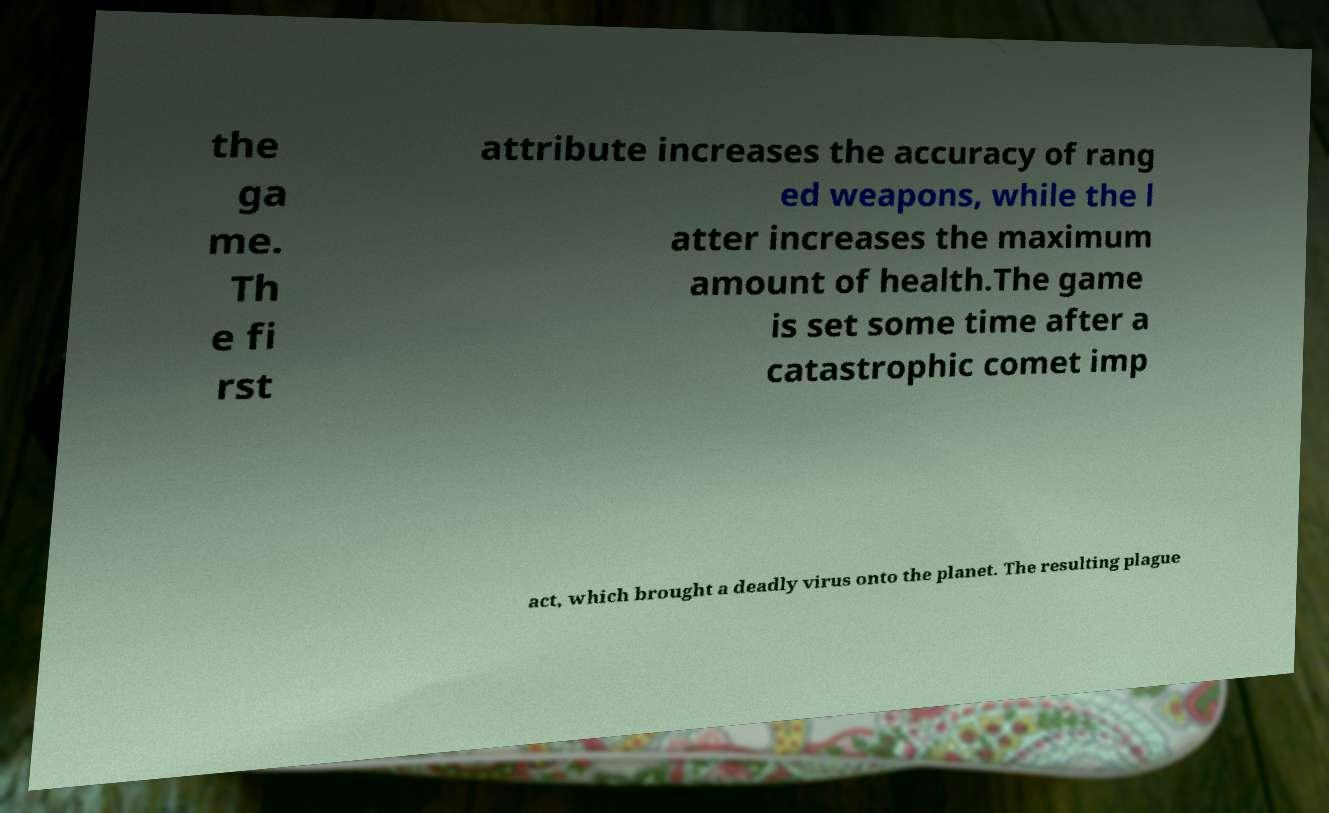Could you extract and type out the text from this image? the ga me. Th e fi rst attribute increases the accuracy of rang ed weapons, while the l atter increases the maximum amount of health.The game is set some time after a catastrophic comet imp act, which brought a deadly virus onto the planet. The resulting plague 